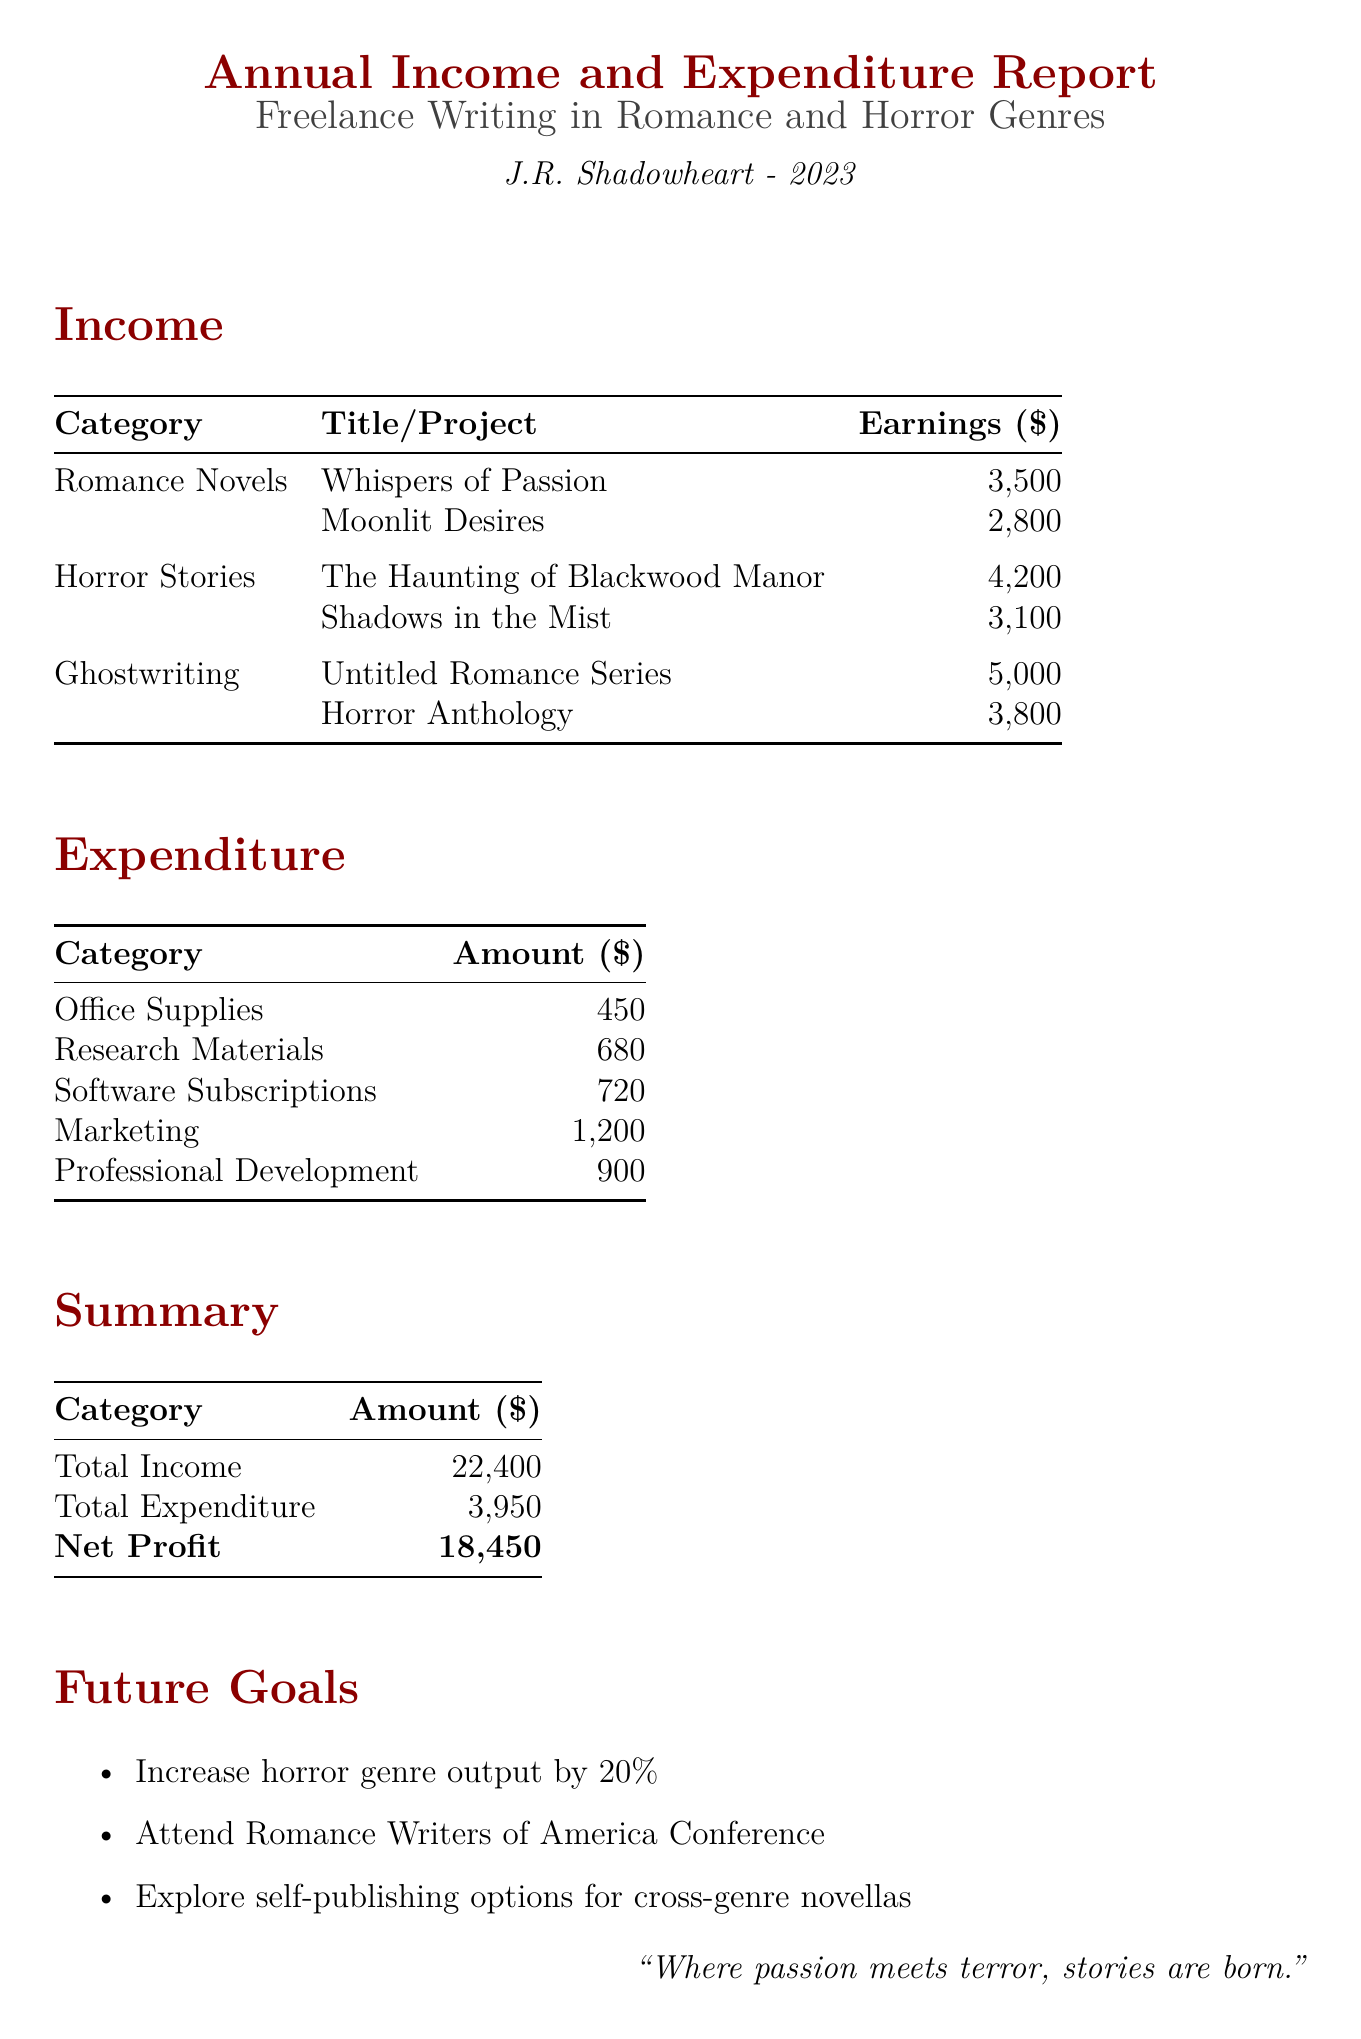What is the total income? The total income is calculated by summing all income sources, which amounts to $3500 + $2800 + $4200 + $3100 + $5000 + $3800 = $22400.
Answer: $22400 What are the expenditures on office supplies? The expenditure on office supplies is specifically listed in the expenditures section of the document as $450.
Answer: $450 Who published "Moonlit Desires"? The publisher of "Moonlit Desires" is mentioned in the income section as Avon Romance.
Answer: Avon Romance What is the net profit? The net profit is derived by subtracting total expenditure from total income, calculated as $22400 - $3950 = $18450.
Answer: $18450 Which horror story earned the most? The highest-earning horror story listed in the document is "The Haunting of Blackwood Manor" with earnings of $4200.
Answer: The Haunting of Blackwood Manor How much was spent on marketing? The marketing expense is mentioned explicitly in the expenditures section of the document as $1200.
Answer: $1200 What is one of the future goals mentioned? One of the objectives listed in the future goals section is to increase horror genre output by 20%.
Answer: Increase horror genre output by 20% How many titles are listed under romance novels? There are two titles listed under romance novels in the income section of the document.
Answer: Two How much did the ghostwriting projects earn in total? The total earnings from ghostwriting projects can be calculated by summing $5000 + $3800, which equals $8800.
Answer: $8800 